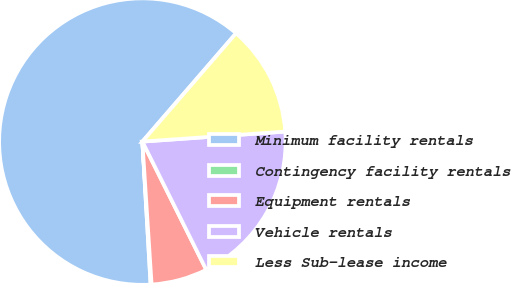Convert chart to OTSL. <chart><loc_0><loc_0><loc_500><loc_500><pie_chart><fcel>Minimum facility rentals<fcel>Contingency facility rentals<fcel>Equipment rentals<fcel>Vehicle rentals<fcel>Less Sub-lease income<nl><fcel>62.27%<fcel>0.11%<fcel>6.33%<fcel>18.76%<fcel>12.54%<nl></chart> 